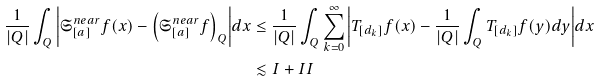Convert formula to latex. <formula><loc_0><loc_0><loc_500><loc_500>\frac { 1 } { | Q | } \int _ { Q } { \left | \mathfrak { S } _ { [ a ] } ^ { n e a r } f ( x ) - \left ( \mathfrak { S } _ { [ a ] } ^ { n e a r } f \right ) _ { Q } \right | } d x & \leq { \frac { 1 } { | Q | } \int _ { Q } { \sum _ { k = 0 } ^ { \infty } { \left | T _ { [ d _ { k } ] } f ( x ) - \frac { 1 } { | Q | } \int _ { Q } { T _ { [ d _ { k } ] } f ( y ) } d y \right | } } d x } \\ & \lesssim I + I I</formula> 